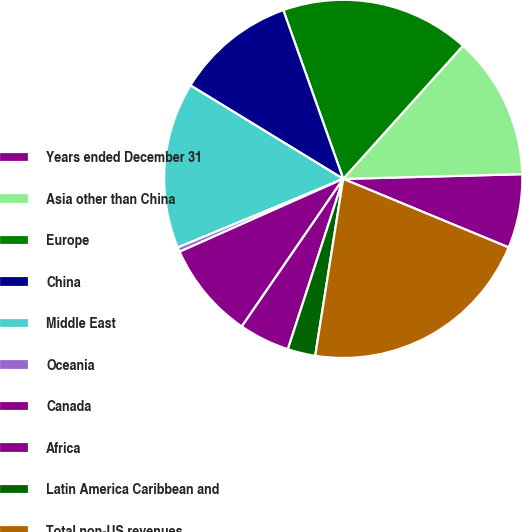Convert chart. <chart><loc_0><loc_0><loc_500><loc_500><pie_chart><fcel>Years ended December 31<fcel>Asia other than China<fcel>Europe<fcel>China<fcel>Middle East<fcel>Oceania<fcel>Canada<fcel>Africa<fcel>Latin America Caribbean and<fcel>Total non-US revenues<nl><fcel>6.67%<fcel>12.92%<fcel>17.09%<fcel>10.83%<fcel>15.0%<fcel>0.41%<fcel>8.75%<fcel>4.58%<fcel>2.5%<fcel>21.25%<nl></chart> 